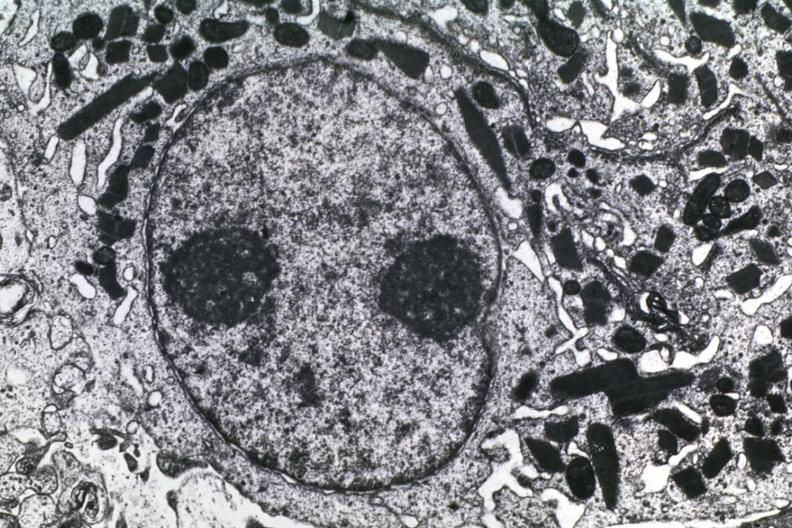s histoplasmosis present?
Answer the question using a single word or phrase. No 